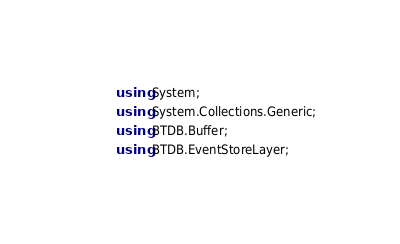<code> <loc_0><loc_0><loc_500><loc_500><_C#_>using System;
using System.Collections.Generic;
using BTDB.Buffer;
using BTDB.EventStoreLayer;</code> 